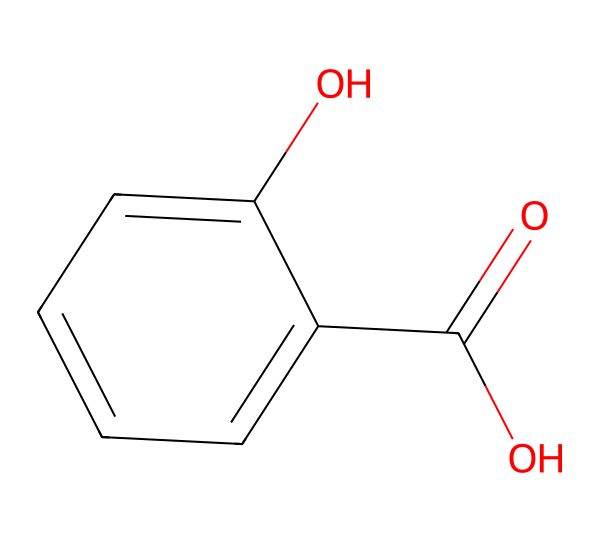How many carbon atoms are in salicylic acid? By examining the SMILES representation, we see the portion 'c1ccccc1' represents a benzene ring which has 6 carbon atoms. Additionally, there is one more carbon in the 'O=C' (carbonyl) structure. Therefore, there are a total of 7 carbon atoms in salicylic acid.
Answer: 7 What functional groups are present in salicylic acid? In the chemical structure, we notice both a carboxylic acid (from 'O=C(O)') and a hydroxyl group (from 'O'). These two functional groups indicate that salicylic acid contains a carboxylic group and a phenolic hydroxyl group.
Answer: carboxylic acid and hydroxyl Is salicylic acid considered an aromatic compound? The presence of the aromatic ring (benzene structure) represented by 'c1ccccc1' confirms that salicylic acid is an aromatic compound, as it has a cyclic structure with continuous overlapping p-orbitals.
Answer: yes What does the presence of the hydroxyl group indicate about the polarity of salicylic acid? The hydroxyl group (-OH) contributes to the overall polarity of the compound, making salicylic acid relatively polar due to its ability to form hydrogen bonds with water. This results in an increased solubility in polar solvents.
Answer: polar What is the significance of salicylic acid in cosmetic formulations? Salicylic acid is known for its effectiveness in treating acne due to its ability to penetrate pores and exfoliate dead skin cells. Its properties help reduce inflammation and prevent future breakouts, which makes it valuable in cosmetic products targeting acne.
Answer: acne treatment How many hydrogen atoms are associated with salicylic acid? By analyzing the SMILES structure, each carbon in the benzene ring typically bonds with 1 hydrogen atom (6 from benzene) and the carbon in the carboxylic acid group generally bonds with 1 oxygen and a hydroxyl group. Therefore, considering the total, there are 6 (from benzene) + 4 (two from carboxylic acid) = 8 hydrogen atoms.
Answer: 6 